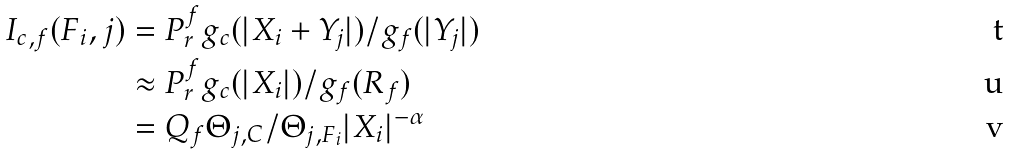<formula> <loc_0><loc_0><loc_500><loc_500>I _ { c , f } ( F _ { i } , j ) & = P _ { r } ^ { f } g _ { c } ( | X _ { i } + Y _ { j } | ) / g _ { f } ( | Y _ { j } | ) \\ & \approx P _ { r } ^ { f } g _ { c } ( | X _ { i } | ) / g _ { f } ( R _ { f } ) \\ & = Q _ { f } \Theta _ { j , C } / \Theta _ { j , F _ { i } } | X _ { i } | ^ { - \alpha }</formula> 